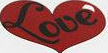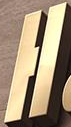What text is displayed in these images sequentially, separated by a semicolon? Love; H 